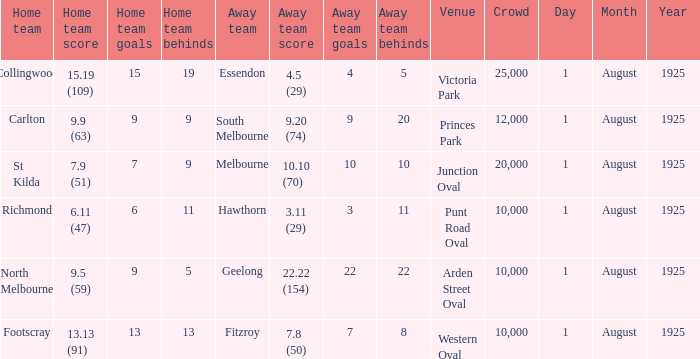When did the match take place that had a home team score of 7.9 (51)? 1 August 1925. 